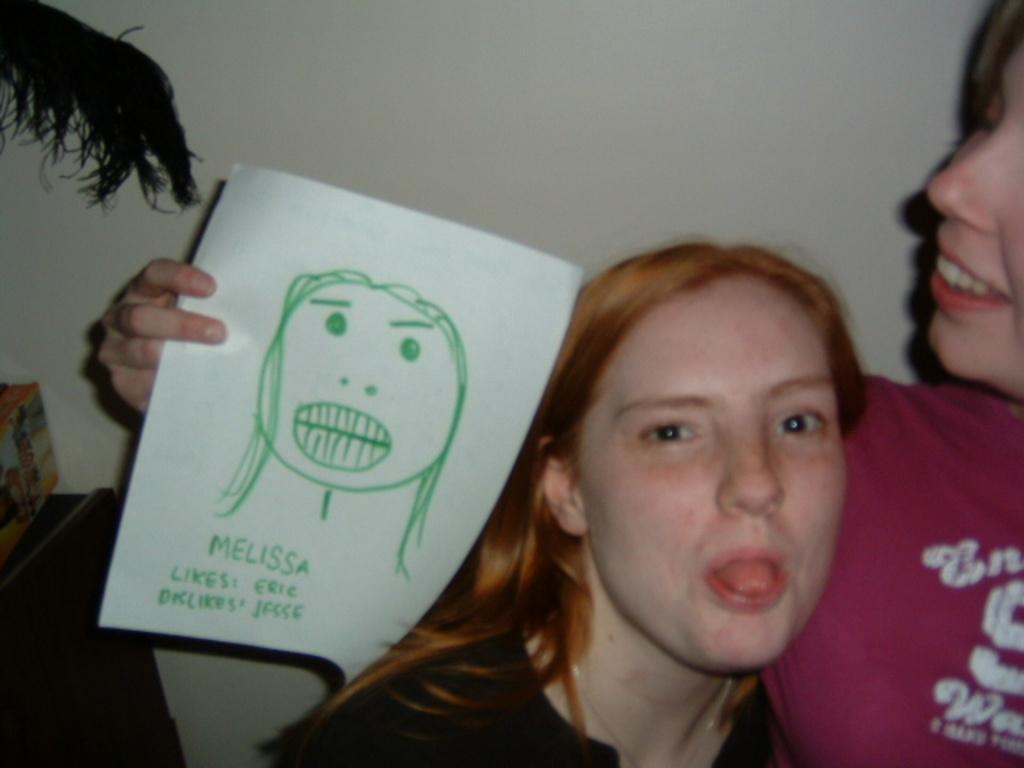Please provide a concise description of this image. In this picture there are two girls on the right side of the image and there is a plant on a desk in the background area of the image, the girl in holding a drawing paper in her hand. 